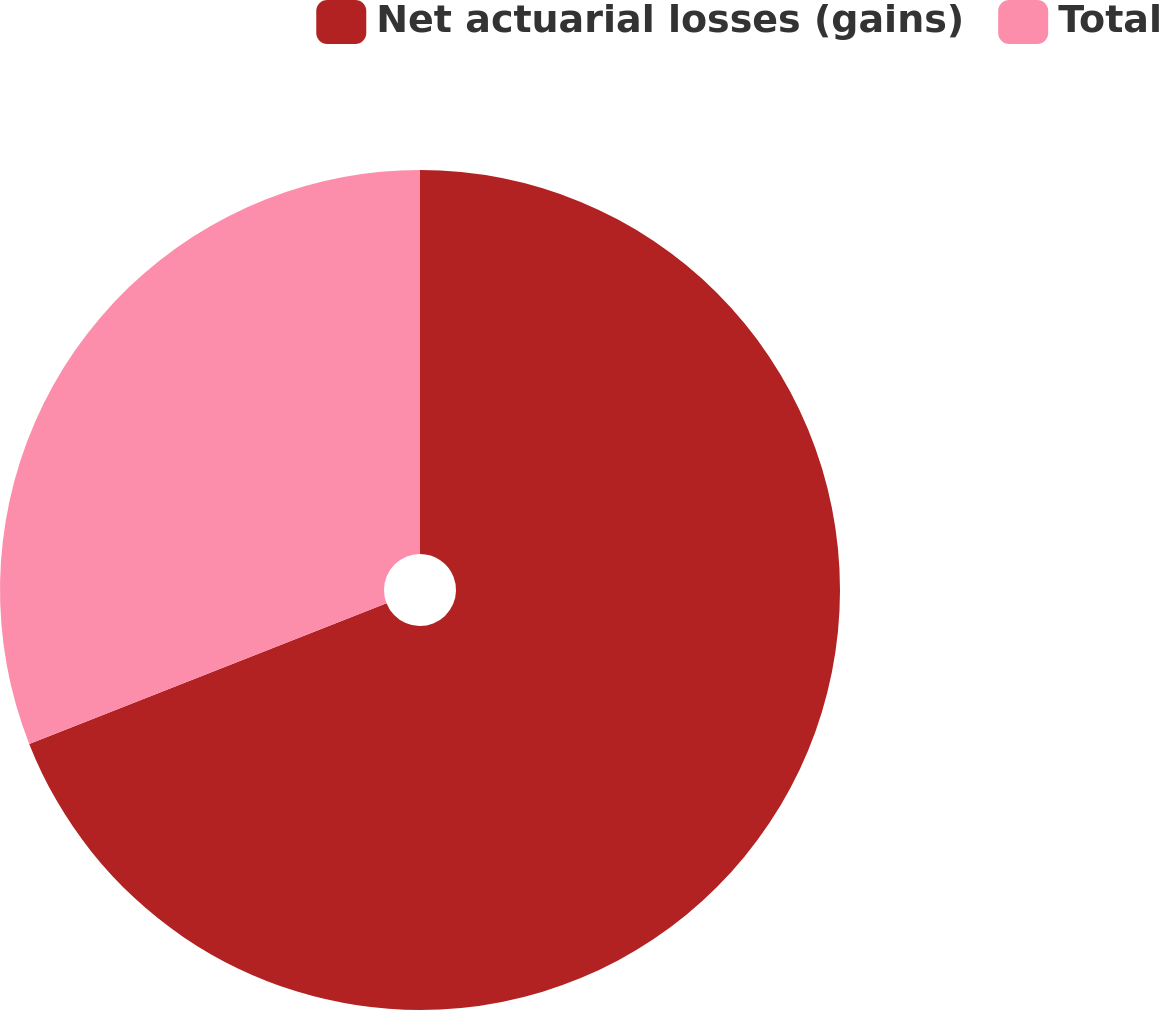<chart> <loc_0><loc_0><loc_500><loc_500><pie_chart><fcel>Net actuarial losses (gains)<fcel>Total<nl><fcel>69.03%<fcel>30.97%<nl></chart> 